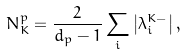<formula> <loc_0><loc_0><loc_500><loc_500>N _ { K } ^ { p } = \frac { 2 } { d _ { p } - 1 } \sum _ { i } \left | \lambda _ { i } ^ { K - } \right | ,</formula> 